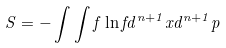Convert formula to latex. <formula><loc_0><loc_0><loc_500><loc_500>S = - \int \int f \ln f d ^ { n + 1 } x d ^ { n + 1 } p</formula> 